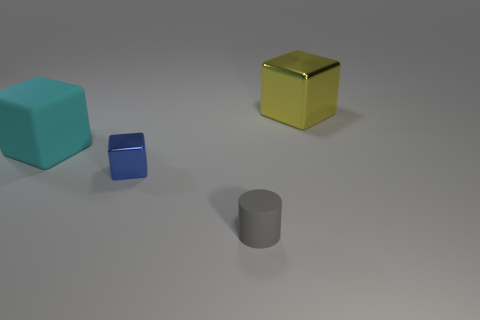Are there more tiny blue objects that are to the left of the blue thing than tiny blocks?
Your response must be concise. No. Are there any large shiny objects of the same color as the big matte thing?
Provide a succinct answer. No. How big is the matte block?
Give a very brief answer. Large. Do the large matte object and the big metal cube have the same color?
Make the answer very short. No. What number of things are large blocks or blue metallic blocks behind the gray matte object?
Your response must be concise. 3. There is a shiny thing that is in front of the metallic block on the right side of the cylinder; how many big blocks are to the left of it?
Offer a terse response. 1. What number of large blue rubber cylinders are there?
Your answer should be very brief. 0. There is a metallic cube that is on the left side of the cylinder; is its size the same as the gray matte cylinder?
Offer a very short reply. Yes. What number of matte objects are either large yellow things or tiny blocks?
Give a very brief answer. 0. How many big cyan matte blocks are behind the big cube that is to the left of the blue object?
Make the answer very short. 0. 